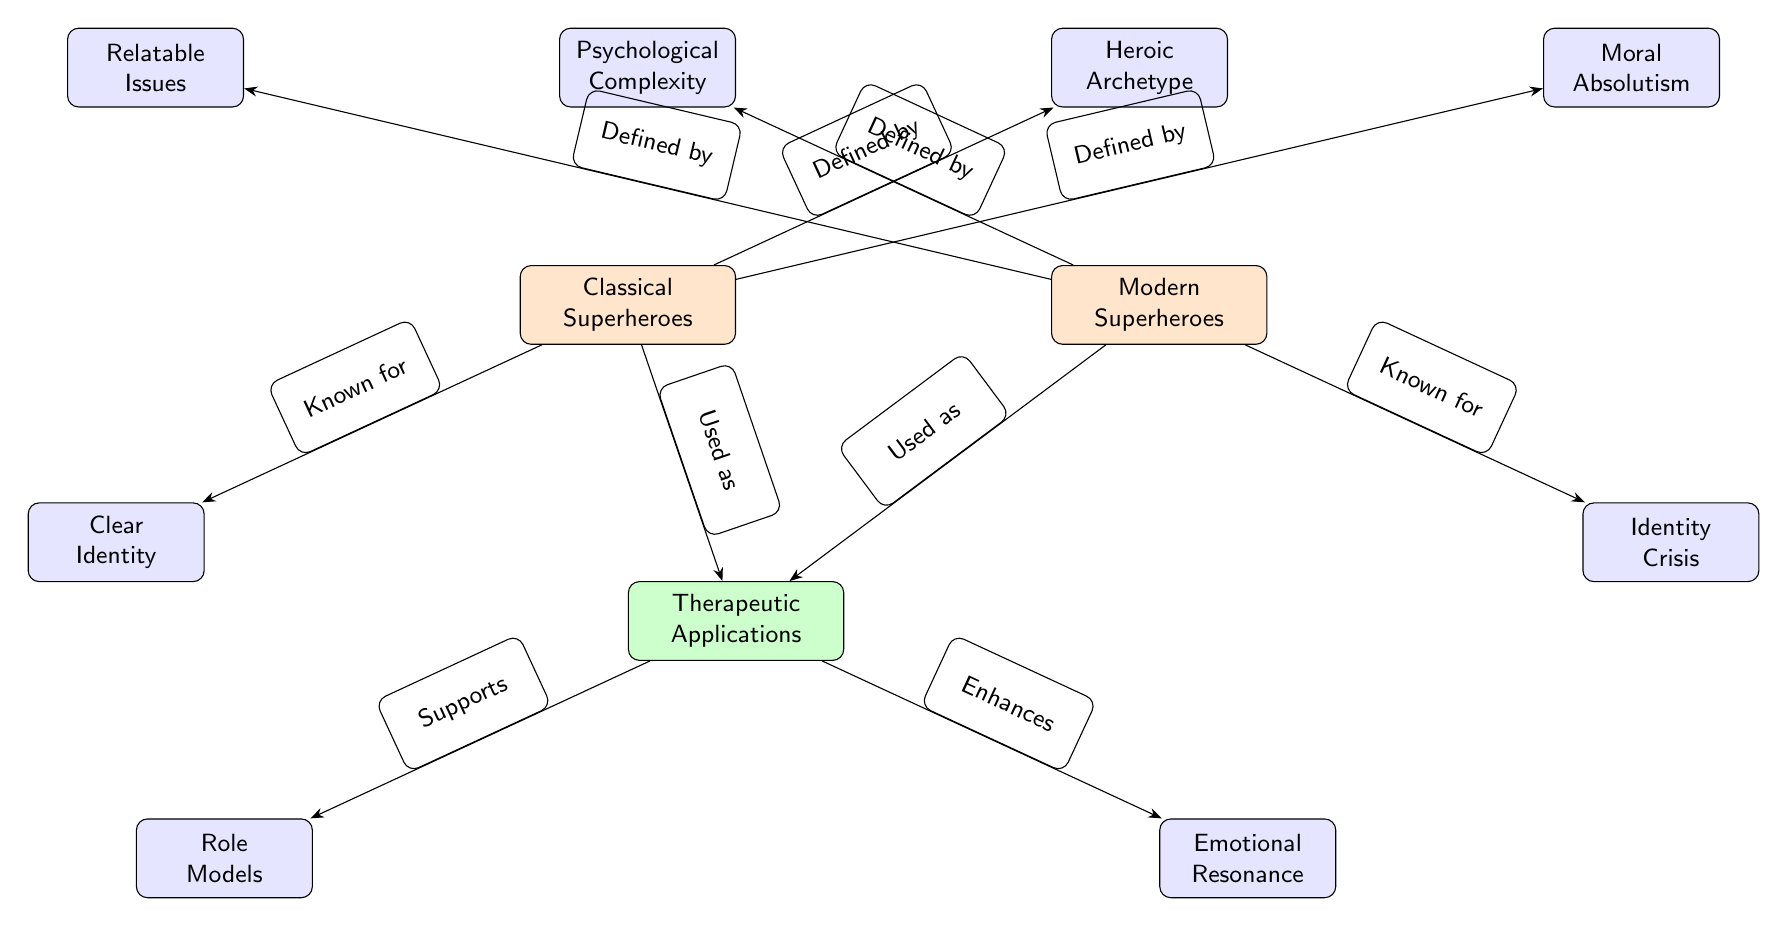What are the two main categories of superheroes in the diagram? The two main categories represented in the diagram are "Classical Superheroes" and "Modern Superheroes" as shown at the top nodes.
Answer: Classical Superheroes, Modern Superheroes How many sub-nodes are connected to "Classical Superheroes"? The classical superheroes node connects to three sub-nodes: "Heroic Archetype", "Moral Absolutism", and "Clear Identity". Thus, there are three sub-nodes.
Answer: 3 What defined Modern Superheroes? The Modern Superheroes node is defined by connecting arrows to "Psychological Complexity" and "Relatable Issues".
Answer: Psychological Complexity, Relatable Issues What are the roles of superheroes used as in therapy? Both Classical and Modern Superheroes are "Used as" therapeutic applications as indicated by the edge leading from both main nodes to the therapy application node.
Answer: Therapeutic Applications Which node indicates that Modern Superheroes deal with identity dilemmas? The node connected to "Modern Superheroes" that indicates identity dilemmas is "Identity Crisis" as shown in the diagram.
Answer: Identity Crisis How do the Therapeutic Applications support the understanding of role models? The "Therapeutic Applications" node supports, indicated by the edge connecting to "Role Models", suggesting that they enhance understanding in therapy sessions.
Answer: Supports What is the relationship between "Clear Identity" and "Classical Superheroes"? "Clear Identity" is a node connected to "Classical Superheroes" indicating it is one of their defining traits as shown by the edge marked "Known for".
Answer: Known for How many edges are pointing towards the "Therapeutic Applications" node? The "Therapeutic Applications" node receives connections from two edges, one from "Classical Superheroes" and one from "Modern Superheroes". Thus, there are two edges pointing towards it.
Answer: 2 What emotional aspect do the therapeutic applications enhance? The therapeutic applications enhance "Emotional Resonance", which is a sub-node connected to therapy as seen in the diagram.
Answer: Emotional Resonance 